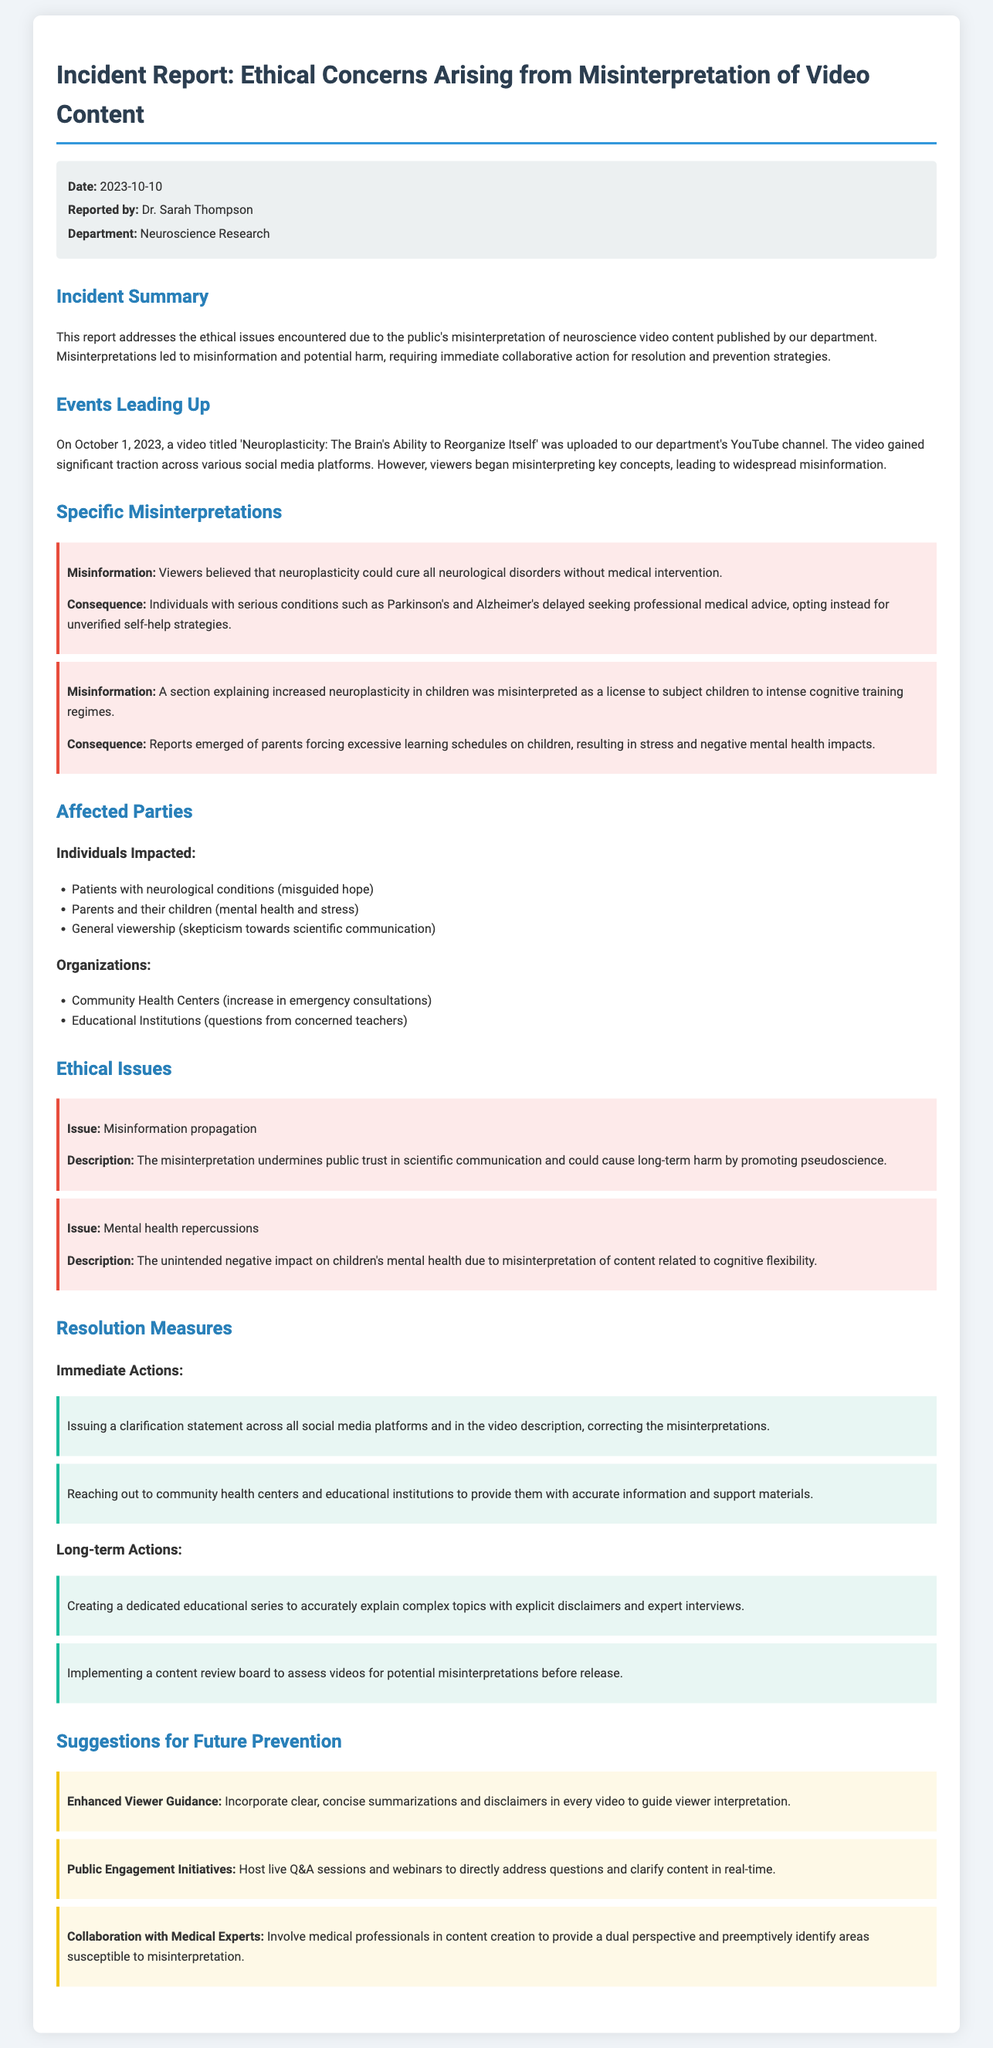What is the date of the incident report? The date is specified in the document under meta-info.
Answer: 2023-10-10 Who reported the incident? The report mentions the name of the person who created the document under meta-info.
Answer: Dr. Sarah Thompson What is the title of the video that caused the incident? The title of the video is provided in the section detailing events leading up to the incident.
Answer: Neuroplasticity: The Brain's Ability to Reorganize Itself What was one consequence of the misinformation regarding neuroplasticity? The document describes the consequences in the specific misinterpretations section.
Answer: Delayed seeking of professional medical advice What ethical issue is related to misinformation propagation? The ethical issues are outlined in the corresponding section, detailing the nature of the concern.
Answer: Undermines public trust in scientific communication What immediate action was taken in response to the incident? The actions taken are listed under resolution measures.
Answer: Issuing a clarification statement What is one suggestion for future prevention mentioned in the report? Suggestions for future prevention can be found in their respective section within the document.
Answer: Enhanced Viewer Guidance How many affected parties are specifically mentioned? The number of affected parties can be derived from the detailed listing in the document.
Answer: Three Who is the primary audience of the document? The audience is implied through the context of the report regarding its purpose and content.
Answer: Neuroscientists and health professionals 